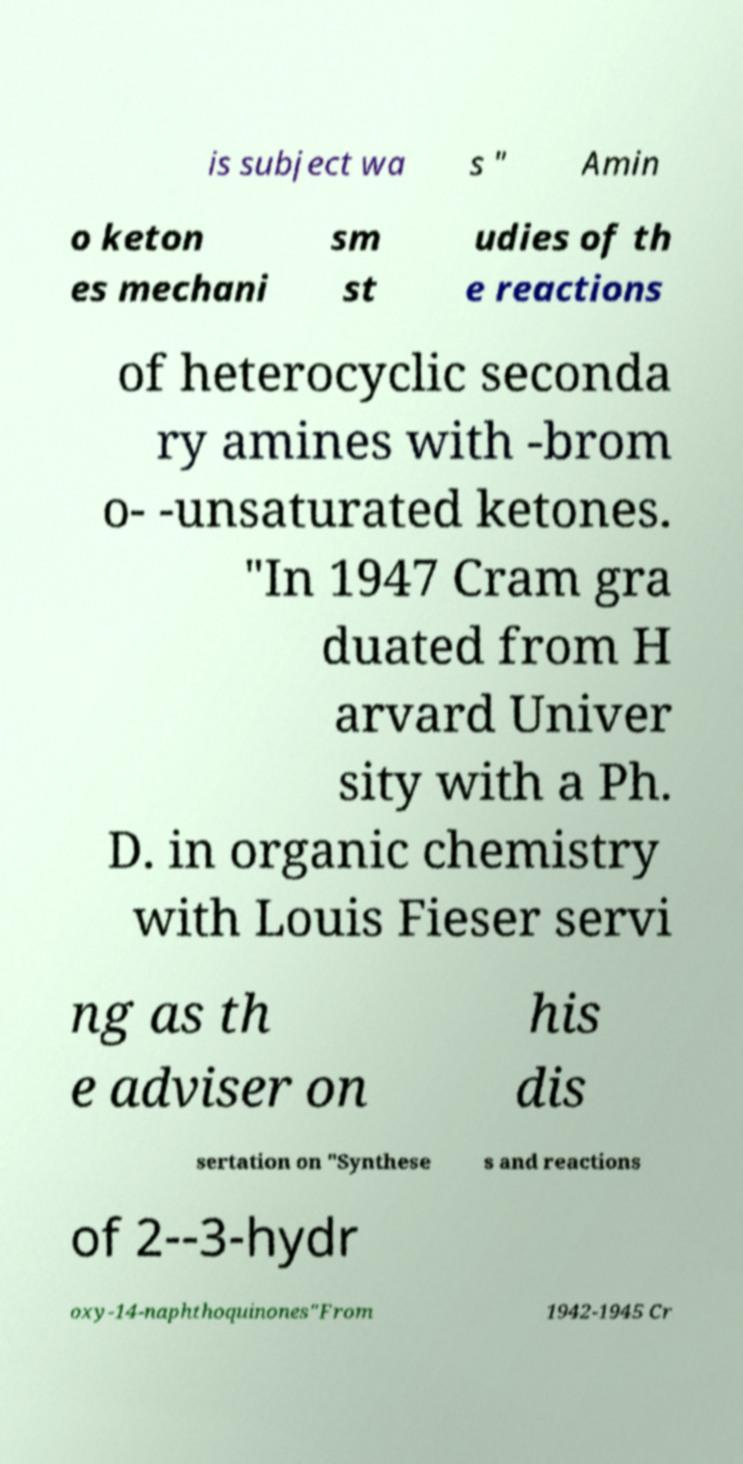What messages or text are displayed in this image? I need them in a readable, typed format. is subject wa s " Amin o keton es mechani sm st udies of th e reactions of heterocyclic seconda ry amines with -brom o- -unsaturated ketones. "In 1947 Cram gra duated from H arvard Univer sity with a Ph. D. in organic chemistry with Louis Fieser servi ng as th e adviser on his dis sertation on "Synthese s and reactions of 2--3-hydr oxy-14-naphthoquinones"From 1942-1945 Cr 